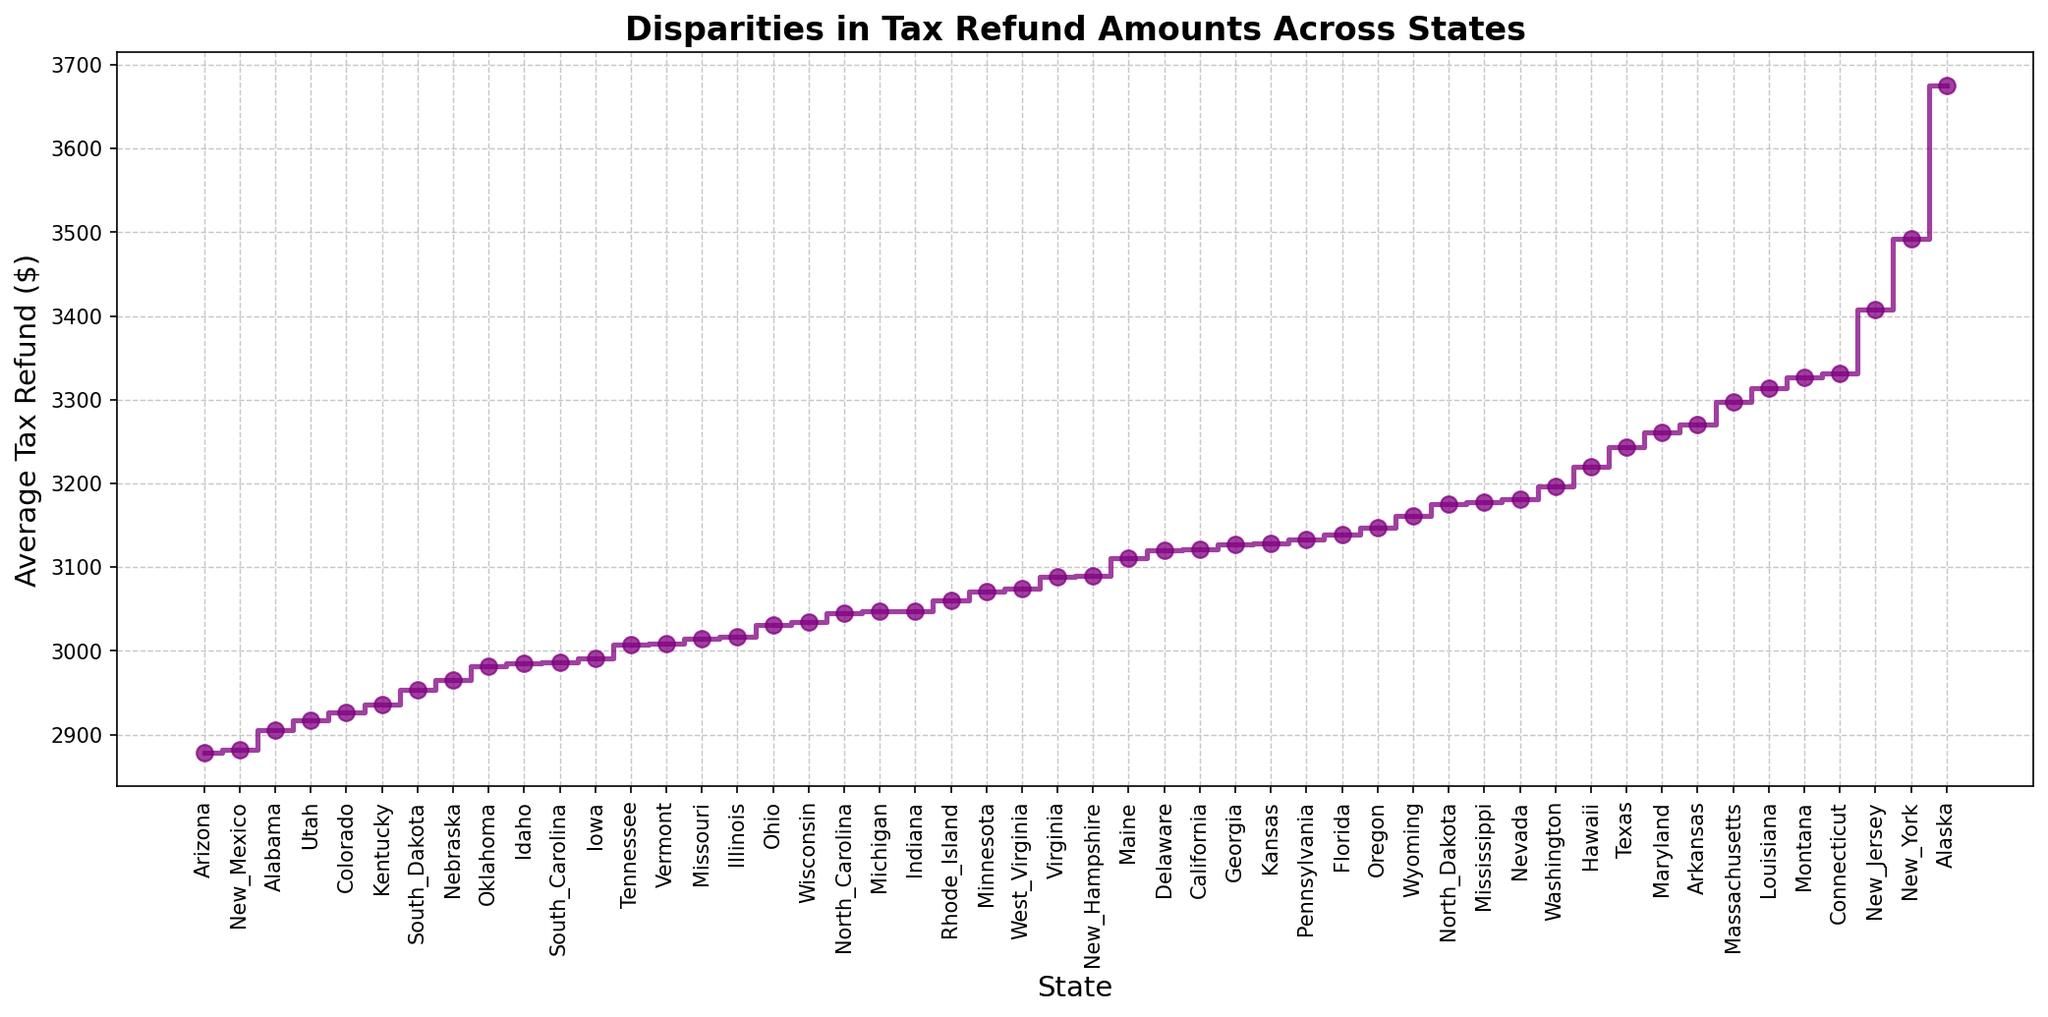What state has the highest average tax refund? The state with the highest point on the y-axis represents the highest average tax refund. Referring to the top of the stairs plot shows that New York has the highest average tax refund.
Answer: New York What states have an average tax refund greater than $3,000 but less than $3,500? Look at the y-axis and identify the states in the middle range of the stairs plot that fall between the lines for $3,000 and $3,500. These states are Illinois, Indiana, Iowa, Kansas, Kentucky, Maryland, Massachusetts, Michigan, Minnesota, Mississippi, Missouri, Montana, Nebraska, Nevada, New Hampshire, New Jersey, North Carolina, North Dakota, Ohio, Oklahoma, Oregon, Pennsylvania, Rhode Island, South Carolina, South Dakota, Tennessee, Texas, Vermont, Virginia, Washington, West Virginia, Wisconsin, Wyoming.
Answer: Illinois, Indiana, Iowa, Kansas, Kentucky, Maryland, Massachusetts, Michigan, Minnesota, Mississippi, Missouri, Montana, Nebraska, Nevada, New Hampshire, New Jersey, North Carolina, North Dakota, Ohio, Oklahoma, Oregon, Pennsylvania, Rhode Island, South Carolina, South Dakota, Tennessee, Texas, Vermont, Virginia, Washington, West Virginia, Wisconsin, Wyoming Which state has a higher average tax refund, Texas or California? Compare the position of Texas and California on the y-axis. Texas is higher on the y-axis than California, indicating a higher average tax refund.
Answer: Texas What is the difference between the average tax refunds of Alaska and Arizona? Find the y-axis positions of Alaska and Arizona. Alaska is at $3,675 and Arizona is at $2,878. Subtract $2,878 from $3,675 to find the difference.
Answer: $797 Which states have an average tax refund closest to the median value? Arrange the refunds in order and identify the median value, which is the middle value. The median in this ordered set is near Indiana and Missouri, with refunds of $3,048 and $3,014, respectively.
Answer: Indiana, Missouri Which state has the lowest average tax refund and what is the amount? The state at the bottom of the stairs plot on the y-axis represents the lowest average tax refund. Alabama is at the bottom with an average refund amount shown on the y-axis at $2,905.
Answer: Alabama, $2,905 What visual attributes help identify the range of average tax refunds across states? The plot uses a vertical position to indicate the amount of the average tax refunds, and lines step up and down to indicate disparities. The color is consistently purple, which directs the focus on the height difference.
Answer: Vertical position, stepped lines What's the average of the three highest average tax refund states? Identify the top three states from the plot: New York ($3,492), New Jersey ($3,408), and Alaska ($3,675). Sum these amounts: $3,492 + $3,408 + $3,675 = $10,575. Divide by 3 to get the average: $10,575 / 3.
Answer: $3,525 